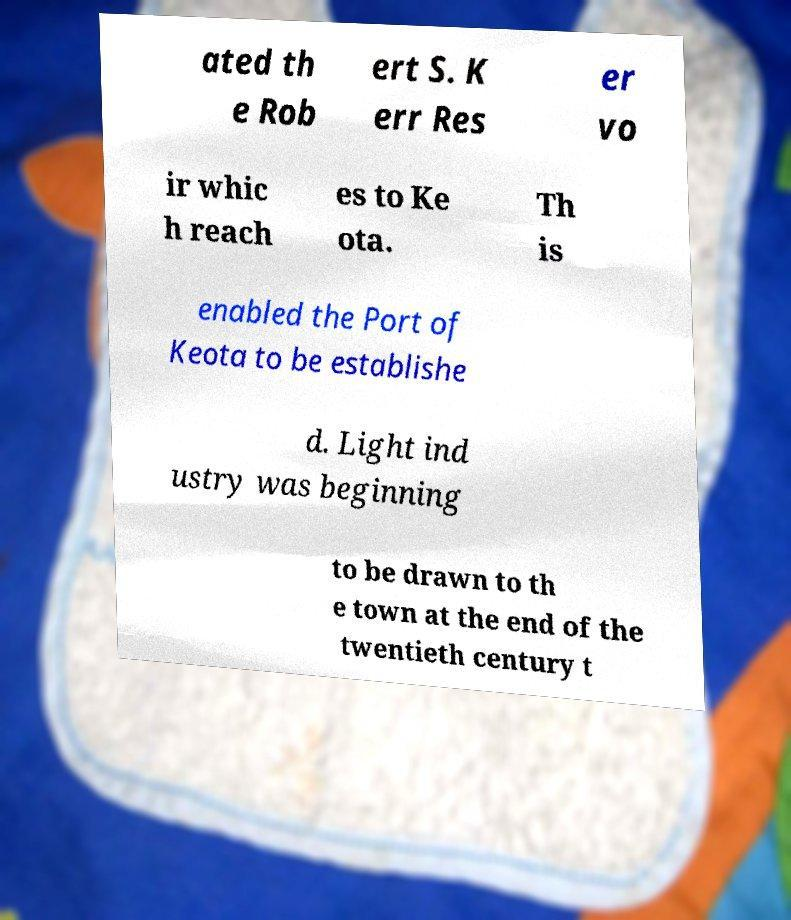Can you read and provide the text displayed in the image?This photo seems to have some interesting text. Can you extract and type it out for me? ated th e Rob ert S. K err Res er vo ir whic h reach es to Ke ota. Th is enabled the Port of Keota to be establishe d. Light ind ustry was beginning to be drawn to th e town at the end of the twentieth century t 